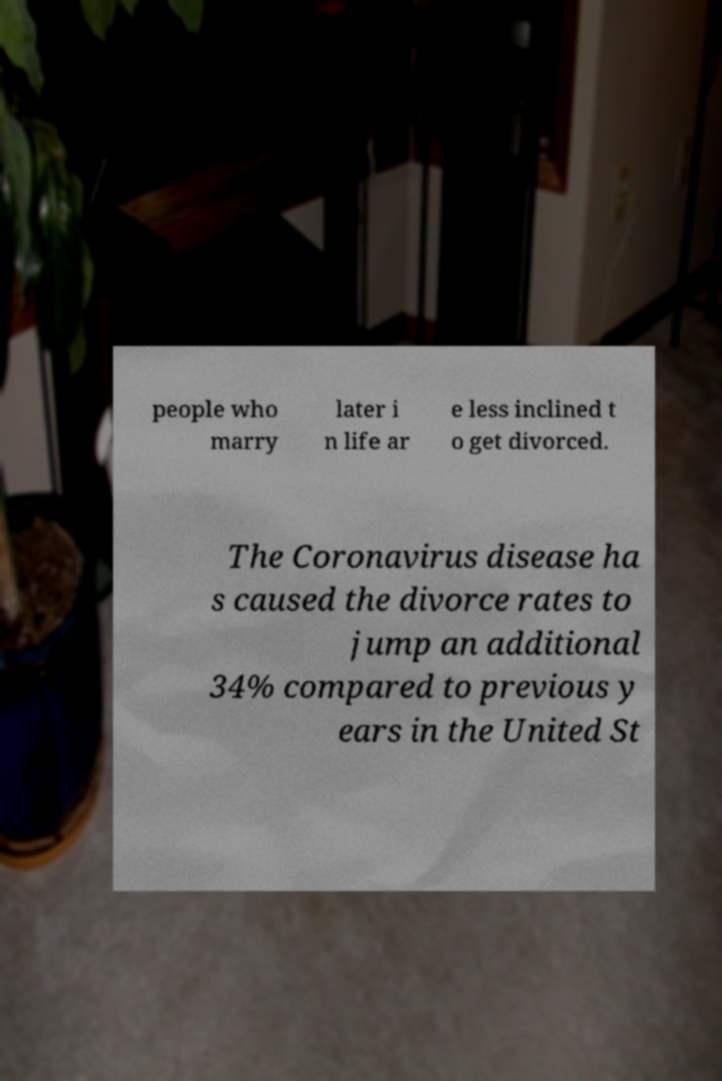Can you accurately transcribe the text from the provided image for me? people who marry later i n life ar e less inclined t o get divorced. The Coronavirus disease ha s caused the divorce rates to jump an additional 34% compared to previous y ears in the United St 